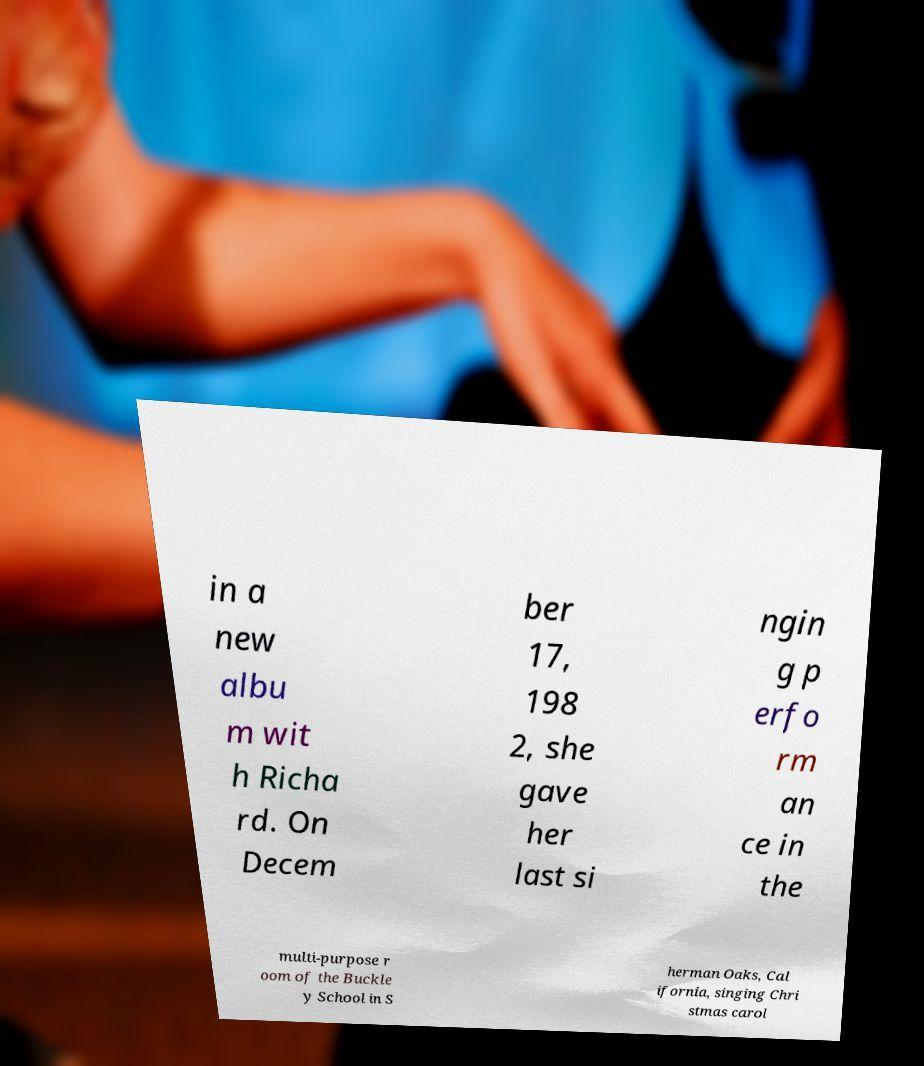Can you read and provide the text displayed in the image?This photo seems to have some interesting text. Can you extract and type it out for me? in a new albu m wit h Richa rd. On Decem ber 17, 198 2, she gave her last si ngin g p erfo rm an ce in the multi-purpose r oom of the Buckle y School in S herman Oaks, Cal ifornia, singing Chri stmas carol 